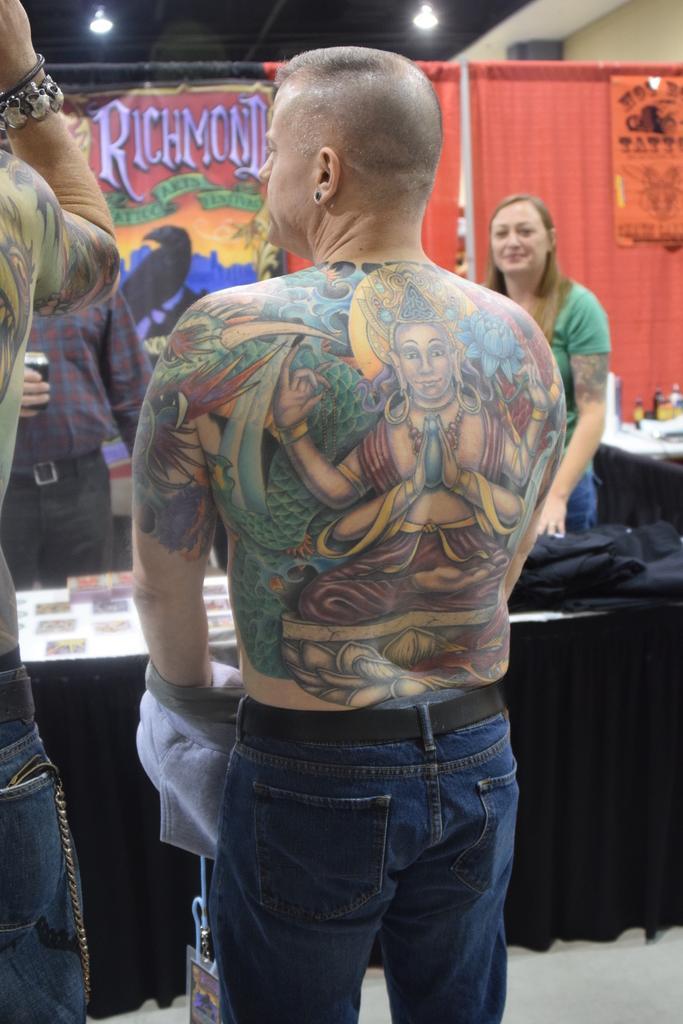Can you describe this image briefly? In this image there are people and there is a table. We can see things placed on the table. In the background there are curtains and board. At the top there are lights. 